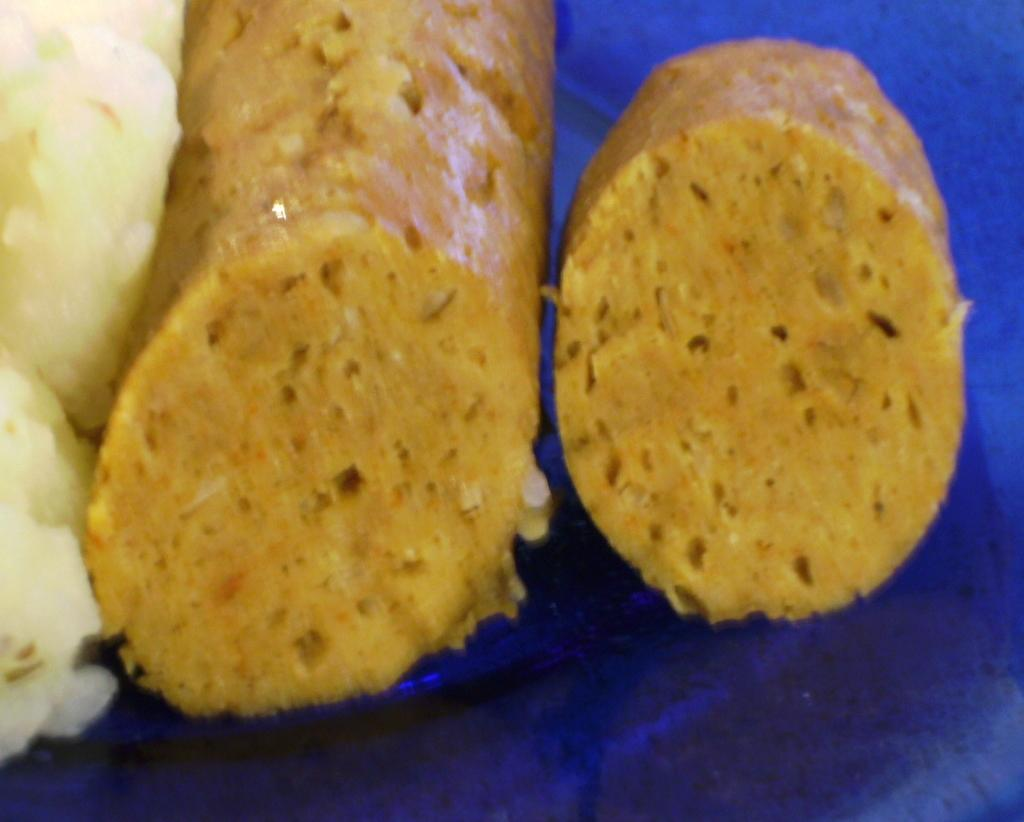What is the focus of the image? The image is zoomed in. What can be seen in the image? There are food items in the image. On what surface are the food items placed? The food items are placed on the surface of a blue object. What type of bone is visible in the image? There is no bone present in the image; it features food items placed on a blue surface. Can you read any writing on the food items in the image? There is no writing visible on the food items in the image. 